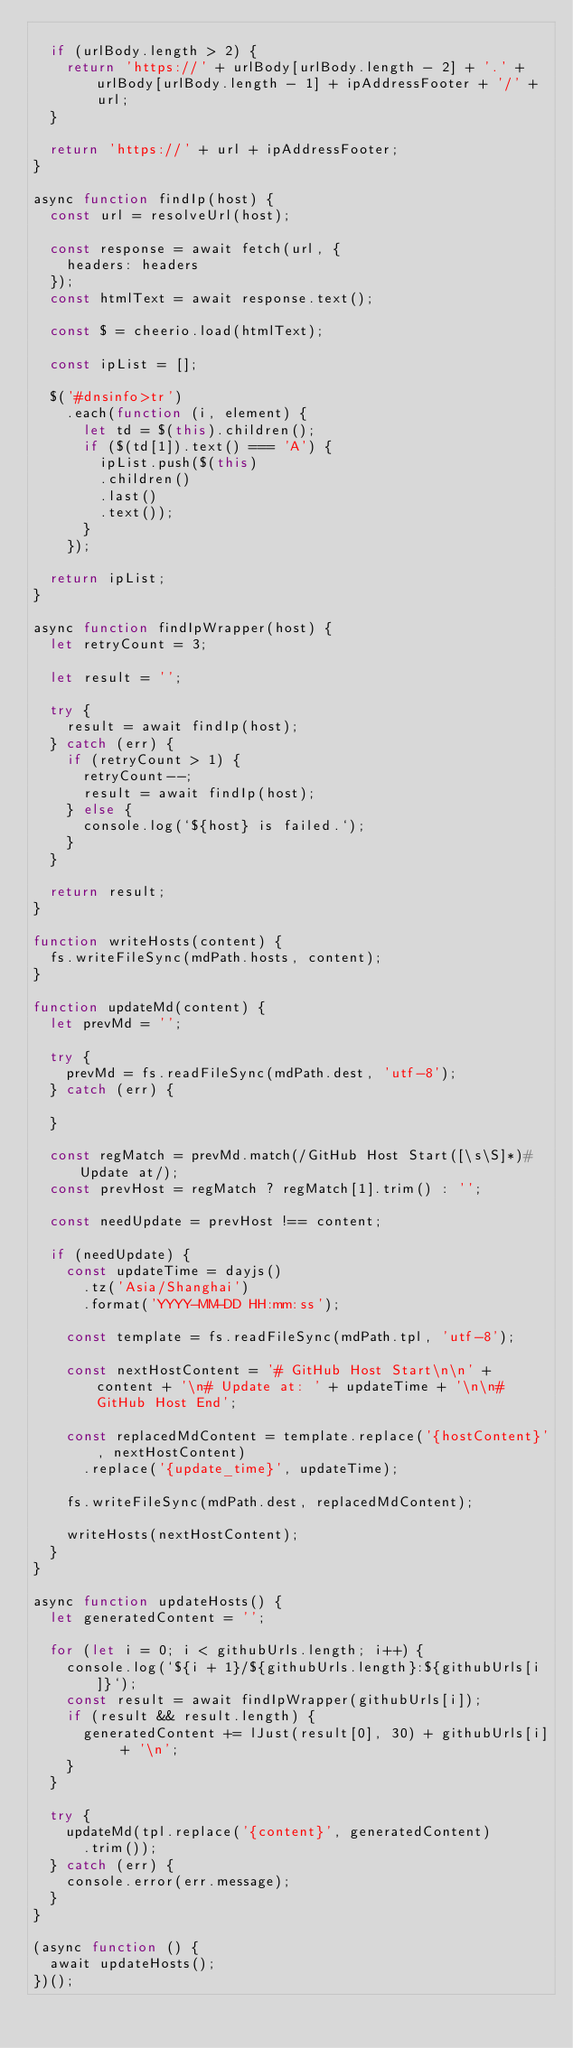Convert code to text. <code><loc_0><loc_0><loc_500><loc_500><_JavaScript_>
  if (urlBody.length > 2) {
    return 'https://' + urlBody[urlBody.length - 2] + '.' + urlBody[urlBody.length - 1] + ipAddressFooter + '/' + url;
  }

  return 'https://' + url + ipAddressFooter;
}

async function findIp(host) {
  const url = resolveUrl(host);

  const response = await fetch(url, {
    headers: headers
  });
  const htmlText = await response.text();

  const $ = cheerio.load(htmlText);

  const ipList = [];

  $('#dnsinfo>tr')
    .each(function (i, element) {
      let td = $(this).children();
      if ($(td[1]).text() === 'A') {
        ipList.push($(this)
        .children()
        .last()
        .text());
      }
    });

  return ipList;
}

async function findIpWrapper(host) {
  let retryCount = 3;

  let result = '';

  try {
    result = await findIp(host);
  } catch (err) {
    if (retryCount > 1) {
      retryCount--;
      result = await findIp(host);
    } else {
      console.log(`${host} is failed.`);
    }
  }

  return result;
}

function writeHosts(content) {
  fs.writeFileSync(mdPath.hosts, content);
}

function updateMd(content) {
  let prevMd = '';

  try {
    prevMd = fs.readFileSync(mdPath.dest, 'utf-8');
  } catch (err) {

  }

  const regMatch = prevMd.match(/GitHub Host Start([\s\S]*)# Update at/);
  const prevHost = regMatch ? regMatch[1].trim() : '';

  const needUpdate = prevHost !== content;

  if (needUpdate) {
    const updateTime = dayjs()
      .tz('Asia/Shanghai')
      .format('YYYY-MM-DD HH:mm:ss');

    const template = fs.readFileSync(mdPath.tpl, 'utf-8');

    const nextHostContent = '# GitHub Host Start\n\n' + content + '\n# Update at: ' + updateTime + '\n\n# GitHub Host End';

    const replacedMdContent = template.replace('{hostContent}', nextHostContent)
      .replace('{update_time}', updateTime);

    fs.writeFileSync(mdPath.dest, replacedMdContent);

    writeHosts(nextHostContent);
  }
}

async function updateHosts() {
  let generatedContent = '';

  for (let i = 0; i < githubUrls.length; i++) {
    console.log(`${i + 1}/${githubUrls.length}:${githubUrls[i]}`);
    const result = await findIpWrapper(githubUrls[i]);
    if (result && result.length) {
      generatedContent += lJust(result[0], 30) + githubUrls[i] + '\n';
    }
  }

  try {
    updateMd(tpl.replace('{content}', generatedContent)
      .trim());
  } catch (err) {
    console.error(err.message);
  }
}

(async function () {
  await updateHosts();
})();
</code> 